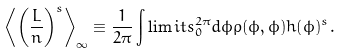Convert formula to latex. <formula><loc_0><loc_0><loc_500><loc_500>\left \langle \left ( \frac { L } { n } \right ) ^ { s } \right \rangle _ { \infty } \equiv \frac { 1 } { 2 \pi } \int \lim i t s _ { 0 } ^ { 2 \pi } d \phi \rho ( \phi , \phi ) h ( \phi ) ^ { s } .</formula> 